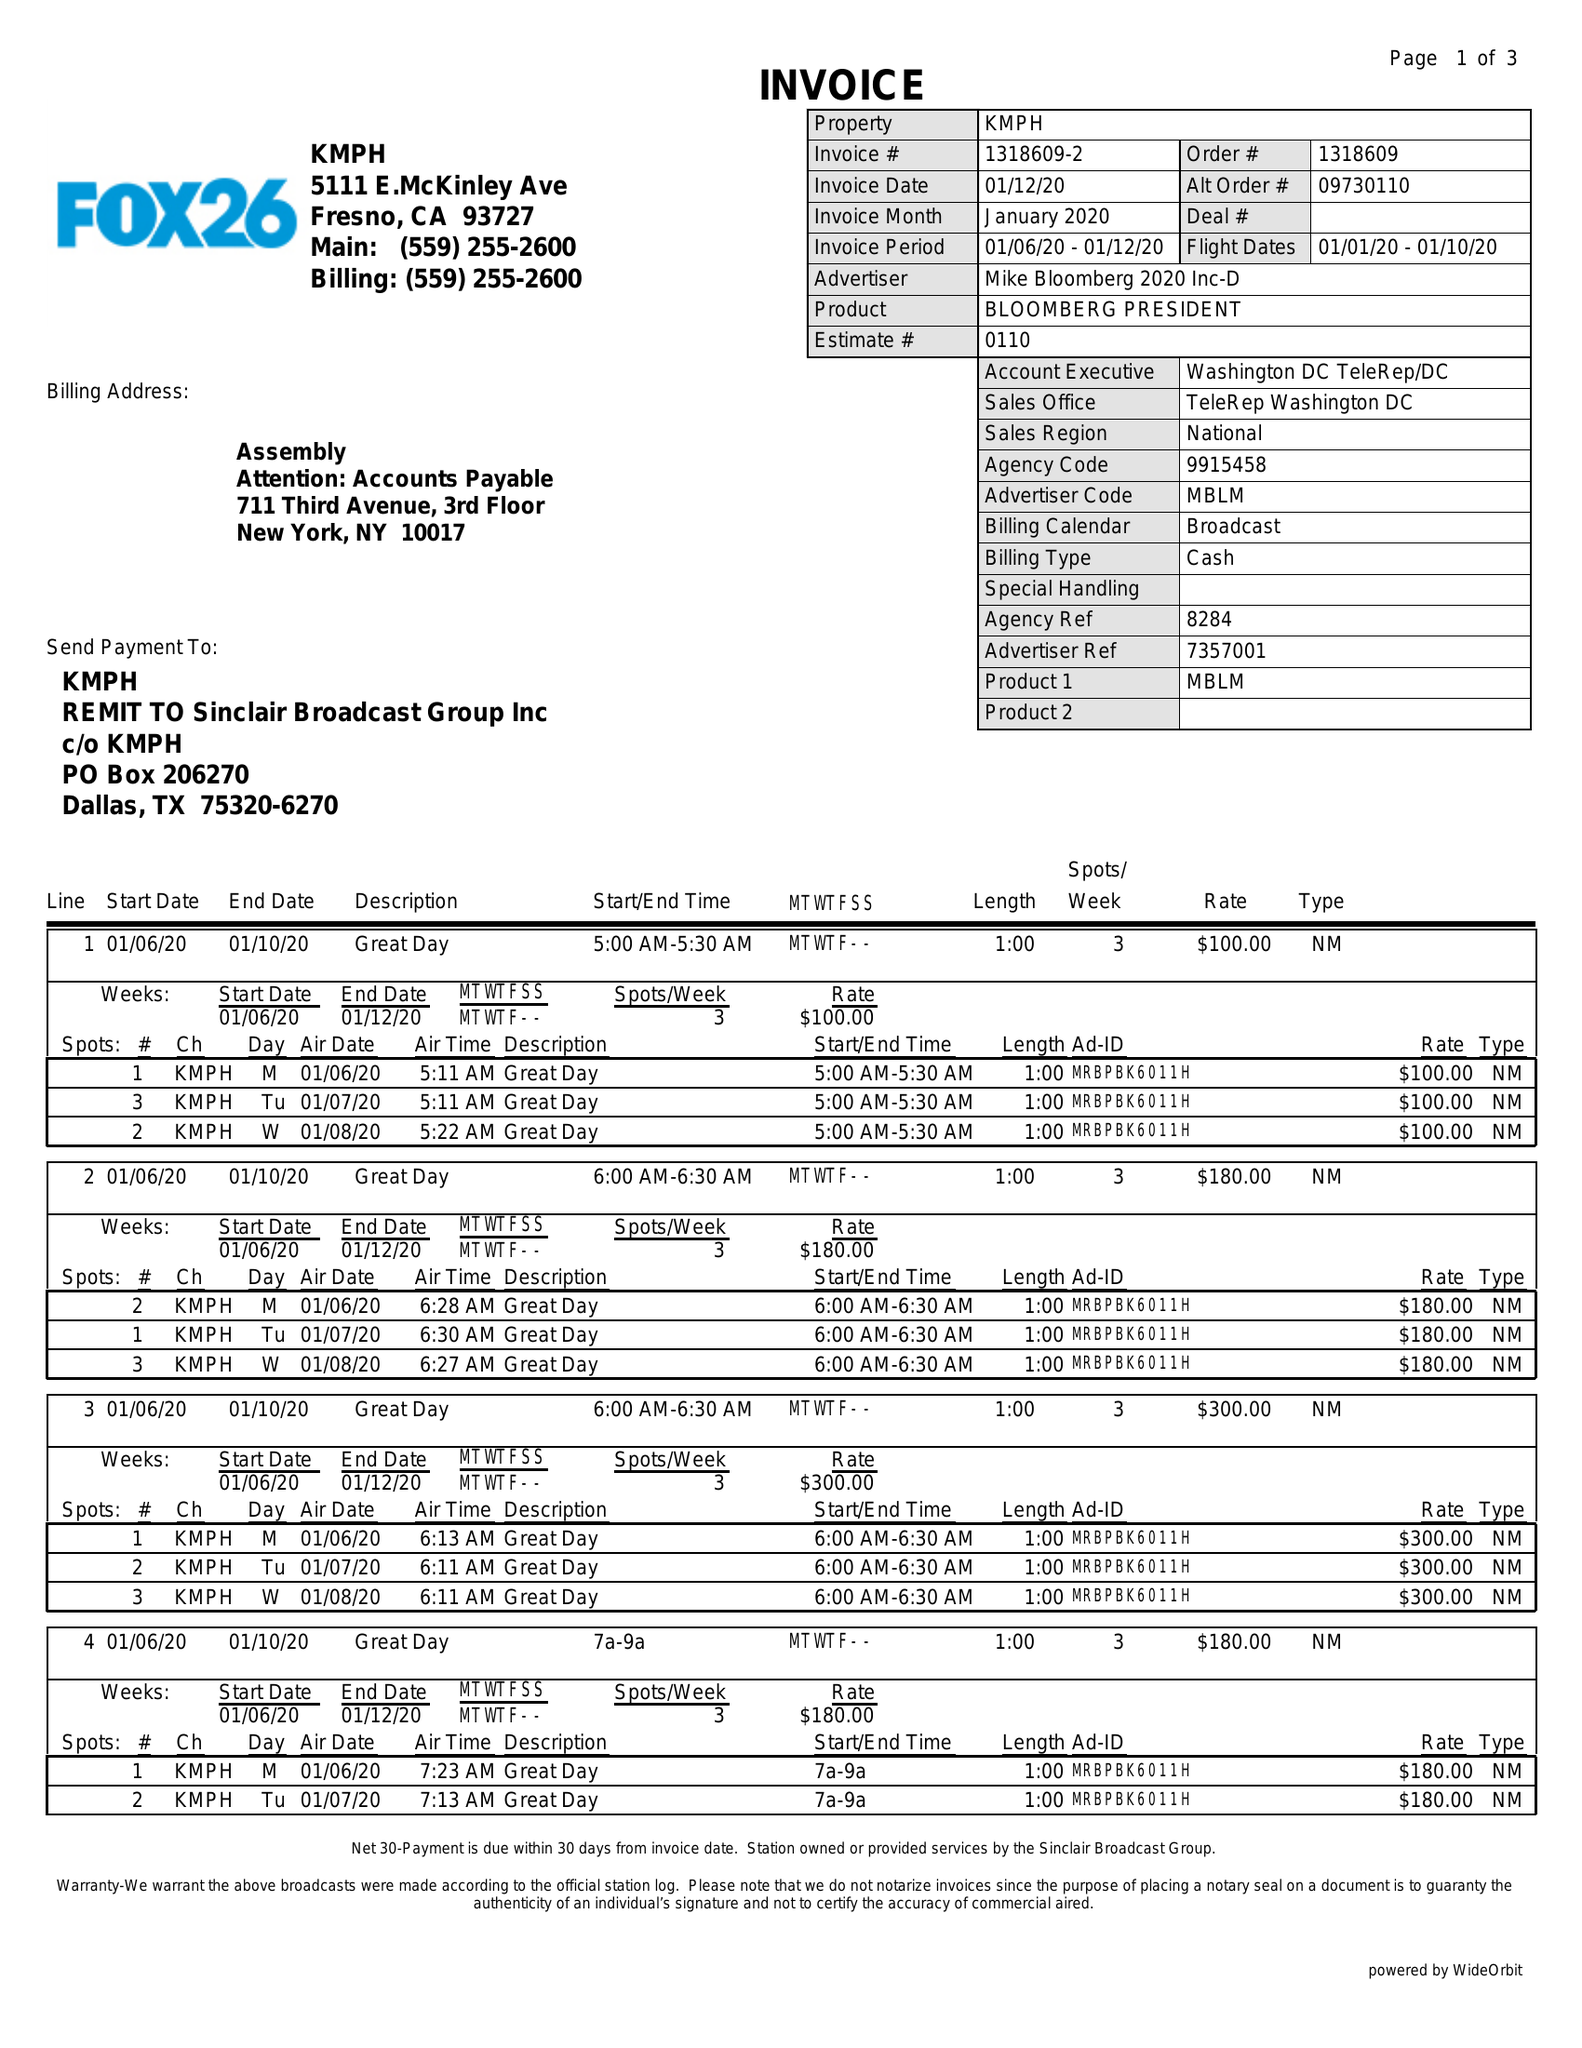What is the value for the advertiser?
Answer the question using a single word or phrase. MIKE BLOOMBERG 2020 INC-D 